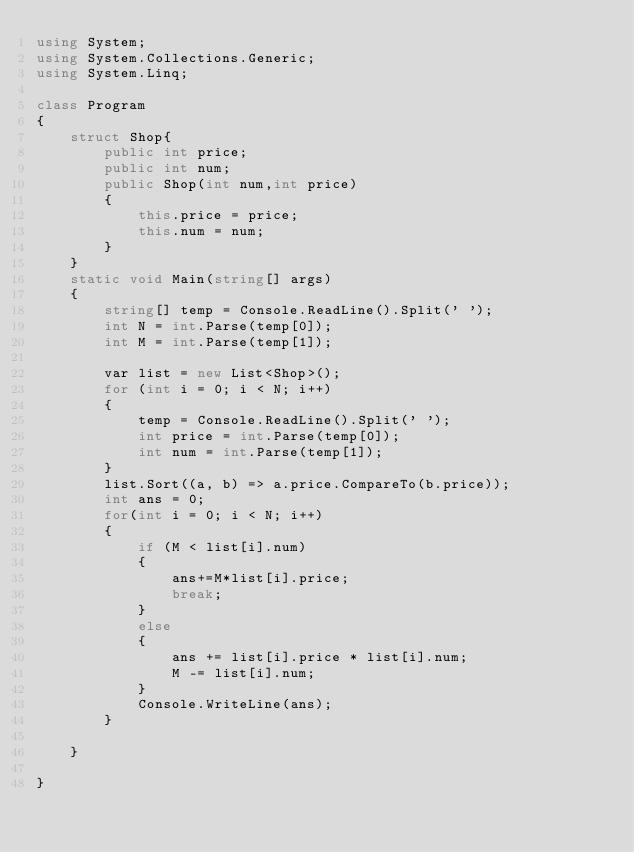Convert code to text. <code><loc_0><loc_0><loc_500><loc_500><_C#_>using System;
using System.Collections.Generic;
using System.Linq;

class Program
{
    struct Shop{
        public int price;
        public int num;
        public Shop(int num,int price)
        {
            this.price = price;
            this.num = num;
        }
    }
    static void Main(string[] args)
    {
        string[] temp = Console.ReadLine().Split(' ');
        int N = int.Parse(temp[0]);
        int M = int.Parse(temp[1]);

        var list = new List<Shop>();
        for (int i = 0; i < N; i++)
        {
            temp = Console.ReadLine().Split(' ');
            int price = int.Parse(temp[0]);
            int num = int.Parse(temp[1]);
        }
        list.Sort((a, b) => a.price.CompareTo(b.price));
        int ans = 0;
        for(int i = 0; i < N; i++)
        {
            if (M < list[i].num)
            {
                ans+=M*list[i].price;
                break;
            }
            else
            {
                ans += list[i].price * list[i].num;
                M -= list[i].num;
            }
            Console.WriteLine(ans);
        }

    }

}
</code> 